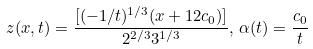Convert formula to latex. <formula><loc_0><loc_0><loc_500><loc_500>z ( x , t ) = \frac { [ ( - 1 / t ) ^ { 1 / 3 } ( x + 1 2 c _ { 0 } ) ] } { 2 ^ { 2 / 3 } 3 ^ { 1 / 3 } } , \, \alpha ( t ) = \frac { c _ { 0 } } { t }</formula> 